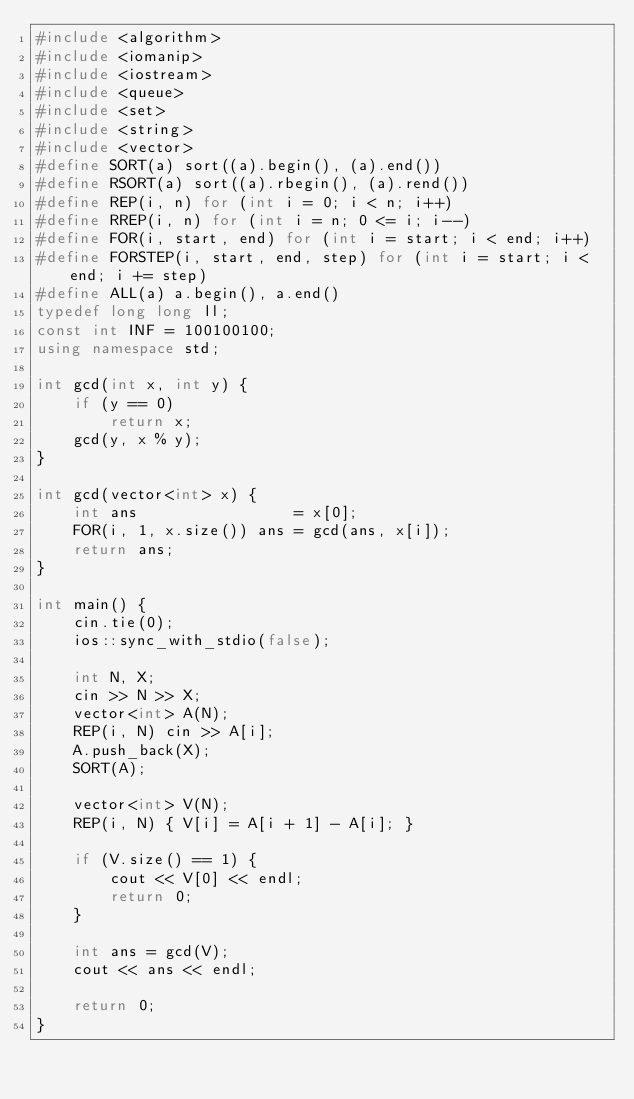<code> <loc_0><loc_0><loc_500><loc_500><_C++_>#include <algorithm>
#include <iomanip>
#include <iostream>
#include <queue>
#include <set>
#include <string>
#include <vector>
#define SORT(a) sort((a).begin(), (a).end())
#define RSORT(a) sort((a).rbegin(), (a).rend())
#define REP(i, n) for (int i = 0; i < n; i++)
#define RREP(i, n) for (int i = n; 0 <= i; i--)
#define FOR(i, start, end) for (int i = start; i < end; i++)
#define FORSTEP(i, start, end, step) for (int i = start; i < end; i += step)
#define ALL(a) a.begin(), a.end()
typedef long long ll;
const int INF = 100100100;
using namespace std;

int gcd(int x, int y) {
    if (y == 0)
        return x;
    gcd(y, x % y);
}

int gcd(vector<int> x) {
    int ans                 = x[0];
    FOR(i, 1, x.size()) ans = gcd(ans, x[i]);
    return ans;
}

int main() {
    cin.tie(0);
    ios::sync_with_stdio(false);

    int N, X;
    cin >> N >> X;
    vector<int> A(N);
    REP(i, N) cin >> A[i];
    A.push_back(X);
    SORT(A);

    vector<int> V(N);
    REP(i, N) { V[i] = A[i + 1] - A[i]; }

    if (V.size() == 1) {
        cout << V[0] << endl;
        return 0;
    }

    int ans = gcd(V);
    cout << ans << endl;

    return 0;
}</code> 